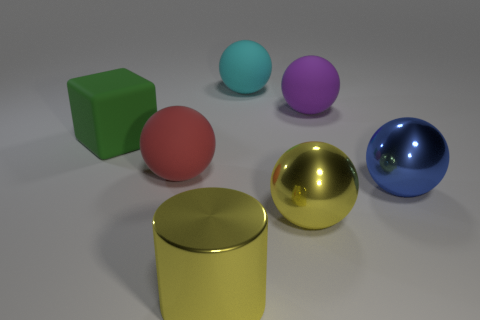Subtract all purple spheres. How many spheres are left? 4 Subtract all blue spheres. How many spheres are left? 4 Subtract 1 spheres. How many spheres are left? 4 Subtract all brown balls. Subtract all cyan cubes. How many balls are left? 5 Add 2 large cyan objects. How many objects exist? 9 Subtract all blocks. How many objects are left? 6 Add 3 large green objects. How many large green objects are left? 4 Add 5 red things. How many red things exist? 6 Subtract 1 red balls. How many objects are left? 6 Subtract all blue things. Subtract all large blue things. How many objects are left? 5 